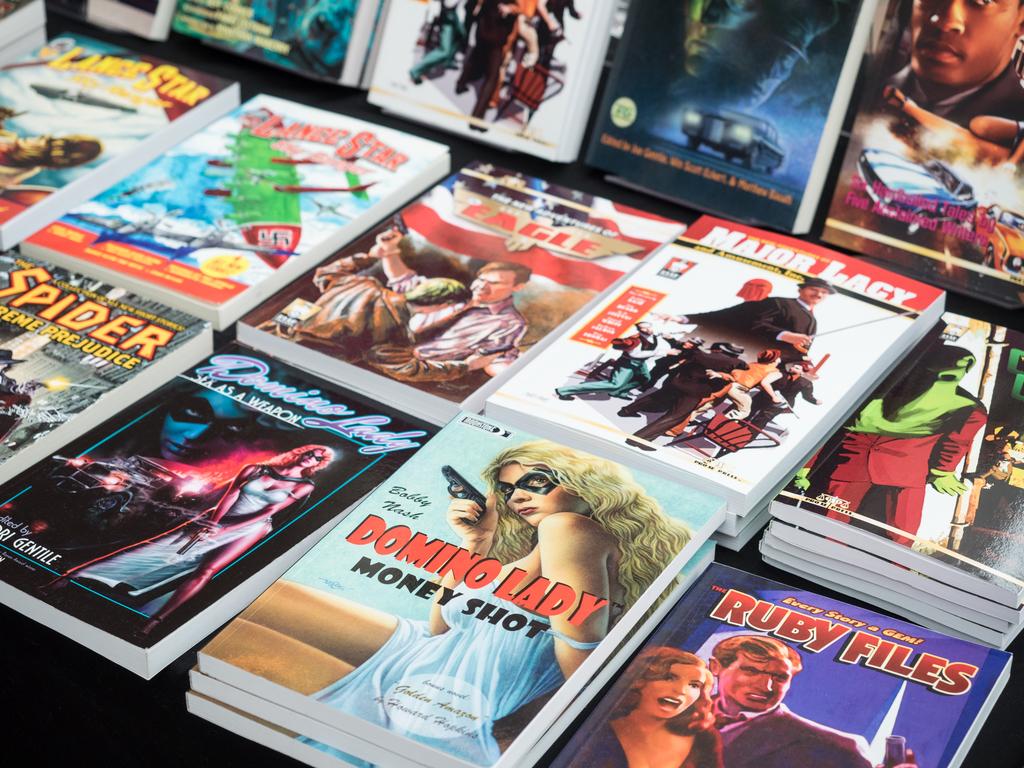What is the title of one of these comics?
Offer a very short reply. Ruby files. What´s the name of the comic on the left bottom?
Ensure brevity in your answer.  Spider. 